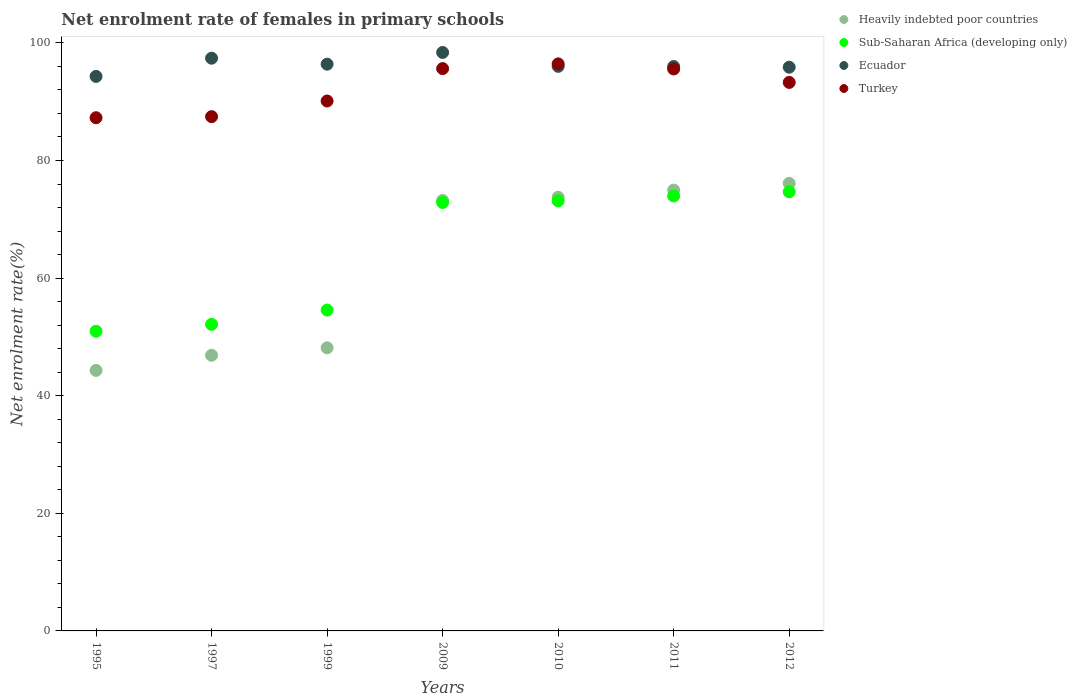What is the net enrolment rate of females in primary schools in Ecuador in 2009?
Keep it short and to the point. 98.37. Across all years, what is the maximum net enrolment rate of females in primary schools in Sub-Saharan Africa (developing only)?
Keep it short and to the point. 74.68. Across all years, what is the minimum net enrolment rate of females in primary schools in Heavily indebted poor countries?
Your answer should be very brief. 44.31. What is the total net enrolment rate of females in primary schools in Turkey in the graph?
Give a very brief answer. 645.75. What is the difference between the net enrolment rate of females in primary schools in Turkey in 2009 and that in 2010?
Your answer should be very brief. -0.8. What is the difference between the net enrolment rate of females in primary schools in Ecuador in 2011 and the net enrolment rate of females in primary schools in Sub-Saharan Africa (developing only) in 2010?
Your response must be concise. 22.84. What is the average net enrolment rate of females in primary schools in Heavily indebted poor countries per year?
Offer a very short reply. 62.48. In the year 2009, what is the difference between the net enrolment rate of females in primary schools in Sub-Saharan Africa (developing only) and net enrolment rate of females in primary schools in Ecuador?
Your response must be concise. -25.51. What is the ratio of the net enrolment rate of females in primary schools in Sub-Saharan Africa (developing only) in 1997 to that in 2011?
Ensure brevity in your answer.  0.7. Is the difference between the net enrolment rate of females in primary schools in Sub-Saharan Africa (developing only) in 1995 and 2009 greater than the difference between the net enrolment rate of females in primary schools in Ecuador in 1995 and 2009?
Ensure brevity in your answer.  No. What is the difference between the highest and the second highest net enrolment rate of females in primary schools in Heavily indebted poor countries?
Your response must be concise. 1.14. What is the difference between the highest and the lowest net enrolment rate of females in primary schools in Heavily indebted poor countries?
Provide a succinct answer. 31.81. Is the sum of the net enrolment rate of females in primary schools in Turkey in 1997 and 1999 greater than the maximum net enrolment rate of females in primary schools in Sub-Saharan Africa (developing only) across all years?
Ensure brevity in your answer.  Yes. Is it the case that in every year, the sum of the net enrolment rate of females in primary schools in Sub-Saharan Africa (developing only) and net enrolment rate of females in primary schools in Ecuador  is greater than the net enrolment rate of females in primary schools in Turkey?
Your answer should be very brief. Yes. Is the net enrolment rate of females in primary schools in Turkey strictly greater than the net enrolment rate of females in primary schools in Heavily indebted poor countries over the years?
Make the answer very short. Yes. How many years are there in the graph?
Offer a terse response. 7. Does the graph contain any zero values?
Make the answer very short. No. How are the legend labels stacked?
Your answer should be compact. Vertical. What is the title of the graph?
Provide a short and direct response. Net enrolment rate of females in primary schools. What is the label or title of the Y-axis?
Keep it short and to the point. Net enrolment rate(%). What is the Net enrolment rate(%) of Heavily indebted poor countries in 1995?
Your response must be concise. 44.31. What is the Net enrolment rate(%) of Sub-Saharan Africa (developing only) in 1995?
Offer a very short reply. 50.96. What is the Net enrolment rate(%) in Ecuador in 1995?
Your response must be concise. 94.3. What is the Net enrolment rate(%) in Turkey in 1995?
Offer a terse response. 87.27. What is the Net enrolment rate(%) in Heavily indebted poor countries in 1997?
Offer a very short reply. 46.88. What is the Net enrolment rate(%) in Sub-Saharan Africa (developing only) in 1997?
Your response must be concise. 52.14. What is the Net enrolment rate(%) of Ecuador in 1997?
Make the answer very short. 97.4. What is the Net enrolment rate(%) of Turkey in 1997?
Keep it short and to the point. 87.46. What is the Net enrolment rate(%) in Heavily indebted poor countries in 1999?
Your answer should be very brief. 48.15. What is the Net enrolment rate(%) in Sub-Saharan Africa (developing only) in 1999?
Your answer should be compact. 54.56. What is the Net enrolment rate(%) of Ecuador in 1999?
Give a very brief answer. 96.38. What is the Net enrolment rate(%) in Turkey in 1999?
Give a very brief answer. 90.12. What is the Net enrolment rate(%) of Heavily indebted poor countries in 2009?
Your response must be concise. 73.21. What is the Net enrolment rate(%) of Sub-Saharan Africa (developing only) in 2009?
Offer a very short reply. 72.86. What is the Net enrolment rate(%) of Ecuador in 2009?
Make the answer very short. 98.37. What is the Net enrolment rate(%) of Turkey in 2009?
Your answer should be very brief. 95.63. What is the Net enrolment rate(%) of Heavily indebted poor countries in 2010?
Provide a short and direct response. 73.75. What is the Net enrolment rate(%) of Sub-Saharan Africa (developing only) in 2010?
Your answer should be very brief. 73.14. What is the Net enrolment rate(%) in Ecuador in 2010?
Your answer should be compact. 96.01. What is the Net enrolment rate(%) of Turkey in 2010?
Offer a very short reply. 96.43. What is the Net enrolment rate(%) in Heavily indebted poor countries in 2011?
Your answer should be compact. 74.97. What is the Net enrolment rate(%) of Sub-Saharan Africa (developing only) in 2011?
Give a very brief answer. 73.96. What is the Net enrolment rate(%) in Ecuador in 2011?
Make the answer very short. 95.98. What is the Net enrolment rate(%) in Turkey in 2011?
Your answer should be very brief. 95.57. What is the Net enrolment rate(%) of Heavily indebted poor countries in 2012?
Keep it short and to the point. 76.11. What is the Net enrolment rate(%) in Sub-Saharan Africa (developing only) in 2012?
Offer a terse response. 74.68. What is the Net enrolment rate(%) of Ecuador in 2012?
Offer a terse response. 95.87. What is the Net enrolment rate(%) in Turkey in 2012?
Your answer should be compact. 93.28. Across all years, what is the maximum Net enrolment rate(%) in Heavily indebted poor countries?
Ensure brevity in your answer.  76.11. Across all years, what is the maximum Net enrolment rate(%) in Sub-Saharan Africa (developing only)?
Give a very brief answer. 74.68. Across all years, what is the maximum Net enrolment rate(%) of Ecuador?
Offer a terse response. 98.37. Across all years, what is the maximum Net enrolment rate(%) in Turkey?
Offer a terse response. 96.43. Across all years, what is the minimum Net enrolment rate(%) of Heavily indebted poor countries?
Your response must be concise. 44.31. Across all years, what is the minimum Net enrolment rate(%) in Sub-Saharan Africa (developing only)?
Provide a succinct answer. 50.96. Across all years, what is the minimum Net enrolment rate(%) of Ecuador?
Give a very brief answer. 94.3. Across all years, what is the minimum Net enrolment rate(%) of Turkey?
Offer a very short reply. 87.27. What is the total Net enrolment rate(%) in Heavily indebted poor countries in the graph?
Ensure brevity in your answer.  437.37. What is the total Net enrolment rate(%) in Sub-Saharan Africa (developing only) in the graph?
Your response must be concise. 452.31. What is the total Net enrolment rate(%) of Ecuador in the graph?
Offer a terse response. 674.32. What is the total Net enrolment rate(%) of Turkey in the graph?
Provide a short and direct response. 645.75. What is the difference between the Net enrolment rate(%) in Heavily indebted poor countries in 1995 and that in 1997?
Make the answer very short. -2.57. What is the difference between the Net enrolment rate(%) in Sub-Saharan Africa (developing only) in 1995 and that in 1997?
Provide a succinct answer. -1.18. What is the difference between the Net enrolment rate(%) of Ecuador in 1995 and that in 1997?
Provide a short and direct response. -3.1. What is the difference between the Net enrolment rate(%) in Turkey in 1995 and that in 1997?
Keep it short and to the point. -0.18. What is the difference between the Net enrolment rate(%) of Heavily indebted poor countries in 1995 and that in 1999?
Provide a short and direct response. -3.84. What is the difference between the Net enrolment rate(%) in Sub-Saharan Africa (developing only) in 1995 and that in 1999?
Keep it short and to the point. -3.6. What is the difference between the Net enrolment rate(%) of Ecuador in 1995 and that in 1999?
Keep it short and to the point. -2.08. What is the difference between the Net enrolment rate(%) in Turkey in 1995 and that in 1999?
Give a very brief answer. -2.85. What is the difference between the Net enrolment rate(%) of Heavily indebted poor countries in 1995 and that in 2009?
Your answer should be compact. -28.9. What is the difference between the Net enrolment rate(%) of Sub-Saharan Africa (developing only) in 1995 and that in 2009?
Your answer should be very brief. -21.9. What is the difference between the Net enrolment rate(%) in Ecuador in 1995 and that in 2009?
Keep it short and to the point. -4.07. What is the difference between the Net enrolment rate(%) in Turkey in 1995 and that in 2009?
Your answer should be compact. -8.36. What is the difference between the Net enrolment rate(%) of Heavily indebted poor countries in 1995 and that in 2010?
Make the answer very short. -29.44. What is the difference between the Net enrolment rate(%) of Sub-Saharan Africa (developing only) in 1995 and that in 2010?
Make the answer very short. -22.18. What is the difference between the Net enrolment rate(%) in Ecuador in 1995 and that in 2010?
Offer a very short reply. -1.71. What is the difference between the Net enrolment rate(%) of Turkey in 1995 and that in 2010?
Provide a succinct answer. -9.16. What is the difference between the Net enrolment rate(%) of Heavily indebted poor countries in 1995 and that in 2011?
Give a very brief answer. -30.66. What is the difference between the Net enrolment rate(%) in Sub-Saharan Africa (developing only) in 1995 and that in 2011?
Your answer should be compact. -23. What is the difference between the Net enrolment rate(%) in Ecuador in 1995 and that in 2011?
Make the answer very short. -1.68. What is the difference between the Net enrolment rate(%) in Turkey in 1995 and that in 2011?
Offer a terse response. -8.3. What is the difference between the Net enrolment rate(%) of Heavily indebted poor countries in 1995 and that in 2012?
Your answer should be very brief. -31.81. What is the difference between the Net enrolment rate(%) of Sub-Saharan Africa (developing only) in 1995 and that in 2012?
Your answer should be very brief. -23.72. What is the difference between the Net enrolment rate(%) in Ecuador in 1995 and that in 2012?
Give a very brief answer. -1.56. What is the difference between the Net enrolment rate(%) in Turkey in 1995 and that in 2012?
Offer a terse response. -6.01. What is the difference between the Net enrolment rate(%) in Heavily indebted poor countries in 1997 and that in 1999?
Your answer should be compact. -1.27. What is the difference between the Net enrolment rate(%) in Sub-Saharan Africa (developing only) in 1997 and that in 1999?
Provide a short and direct response. -2.42. What is the difference between the Net enrolment rate(%) in Ecuador in 1997 and that in 1999?
Provide a short and direct response. 1.02. What is the difference between the Net enrolment rate(%) in Turkey in 1997 and that in 1999?
Give a very brief answer. -2.66. What is the difference between the Net enrolment rate(%) of Heavily indebted poor countries in 1997 and that in 2009?
Provide a short and direct response. -26.33. What is the difference between the Net enrolment rate(%) of Sub-Saharan Africa (developing only) in 1997 and that in 2009?
Your answer should be compact. -20.72. What is the difference between the Net enrolment rate(%) in Ecuador in 1997 and that in 2009?
Give a very brief answer. -0.97. What is the difference between the Net enrolment rate(%) in Turkey in 1997 and that in 2009?
Your answer should be very brief. -8.17. What is the difference between the Net enrolment rate(%) in Heavily indebted poor countries in 1997 and that in 2010?
Give a very brief answer. -26.87. What is the difference between the Net enrolment rate(%) of Sub-Saharan Africa (developing only) in 1997 and that in 2010?
Provide a succinct answer. -21. What is the difference between the Net enrolment rate(%) in Ecuador in 1997 and that in 2010?
Make the answer very short. 1.38. What is the difference between the Net enrolment rate(%) in Turkey in 1997 and that in 2010?
Keep it short and to the point. -8.97. What is the difference between the Net enrolment rate(%) of Heavily indebted poor countries in 1997 and that in 2011?
Ensure brevity in your answer.  -28.09. What is the difference between the Net enrolment rate(%) in Sub-Saharan Africa (developing only) in 1997 and that in 2011?
Offer a terse response. -21.82. What is the difference between the Net enrolment rate(%) of Ecuador in 1997 and that in 2011?
Provide a short and direct response. 1.41. What is the difference between the Net enrolment rate(%) in Turkey in 1997 and that in 2011?
Offer a very short reply. -8.11. What is the difference between the Net enrolment rate(%) of Heavily indebted poor countries in 1997 and that in 2012?
Keep it short and to the point. -29.24. What is the difference between the Net enrolment rate(%) of Sub-Saharan Africa (developing only) in 1997 and that in 2012?
Provide a short and direct response. -22.54. What is the difference between the Net enrolment rate(%) of Ecuador in 1997 and that in 2012?
Offer a very short reply. 1.53. What is the difference between the Net enrolment rate(%) of Turkey in 1997 and that in 2012?
Provide a short and direct response. -5.82. What is the difference between the Net enrolment rate(%) in Heavily indebted poor countries in 1999 and that in 2009?
Your response must be concise. -25.06. What is the difference between the Net enrolment rate(%) of Sub-Saharan Africa (developing only) in 1999 and that in 2009?
Provide a short and direct response. -18.3. What is the difference between the Net enrolment rate(%) of Ecuador in 1999 and that in 2009?
Offer a terse response. -1.99. What is the difference between the Net enrolment rate(%) in Turkey in 1999 and that in 2009?
Give a very brief answer. -5.51. What is the difference between the Net enrolment rate(%) in Heavily indebted poor countries in 1999 and that in 2010?
Provide a short and direct response. -25.6. What is the difference between the Net enrolment rate(%) in Sub-Saharan Africa (developing only) in 1999 and that in 2010?
Offer a very short reply. -18.58. What is the difference between the Net enrolment rate(%) of Ecuador in 1999 and that in 2010?
Provide a short and direct response. 0.37. What is the difference between the Net enrolment rate(%) in Turkey in 1999 and that in 2010?
Your answer should be compact. -6.31. What is the difference between the Net enrolment rate(%) of Heavily indebted poor countries in 1999 and that in 2011?
Offer a terse response. -26.82. What is the difference between the Net enrolment rate(%) of Sub-Saharan Africa (developing only) in 1999 and that in 2011?
Offer a very short reply. -19.4. What is the difference between the Net enrolment rate(%) of Ecuador in 1999 and that in 2011?
Provide a short and direct response. 0.4. What is the difference between the Net enrolment rate(%) in Turkey in 1999 and that in 2011?
Provide a short and direct response. -5.45. What is the difference between the Net enrolment rate(%) in Heavily indebted poor countries in 1999 and that in 2012?
Ensure brevity in your answer.  -27.97. What is the difference between the Net enrolment rate(%) in Sub-Saharan Africa (developing only) in 1999 and that in 2012?
Offer a terse response. -20.12. What is the difference between the Net enrolment rate(%) in Ecuador in 1999 and that in 2012?
Your response must be concise. 0.52. What is the difference between the Net enrolment rate(%) of Turkey in 1999 and that in 2012?
Provide a short and direct response. -3.16. What is the difference between the Net enrolment rate(%) in Heavily indebted poor countries in 2009 and that in 2010?
Your response must be concise. -0.54. What is the difference between the Net enrolment rate(%) in Sub-Saharan Africa (developing only) in 2009 and that in 2010?
Your answer should be very brief. -0.28. What is the difference between the Net enrolment rate(%) of Ecuador in 2009 and that in 2010?
Your response must be concise. 2.36. What is the difference between the Net enrolment rate(%) of Turkey in 2009 and that in 2010?
Give a very brief answer. -0.8. What is the difference between the Net enrolment rate(%) of Heavily indebted poor countries in 2009 and that in 2011?
Your answer should be very brief. -1.76. What is the difference between the Net enrolment rate(%) of Sub-Saharan Africa (developing only) in 2009 and that in 2011?
Your answer should be very brief. -1.1. What is the difference between the Net enrolment rate(%) of Ecuador in 2009 and that in 2011?
Your response must be concise. 2.39. What is the difference between the Net enrolment rate(%) of Turkey in 2009 and that in 2011?
Your answer should be compact. 0.06. What is the difference between the Net enrolment rate(%) in Heavily indebted poor countries in 2009 and that in 2012?
Offer a very short reply. -2.91. What is the difference between the Net enrolment rate(%) in Sub-Saharan Africa (developing only) in 2009 and that in 2012?
Your response must be concise. -1.82. What is the difference between the Net enrolment rate(%) of Ecuador in 2009 and that in 2012?
Give a very brief answer. 2.5. What is the difference between the Net enrolment rate(%) in Turkey in 2009 and that in 2012?
Your response must be concise. 2.35. What is the difference between the Net enrolment rate(%) in Heavily indebted poor countries in 2010 and that in 2011?
Provide a succinct answer. -1.22. What is the difference between the Net enrolment rate(%) in Sub-Saharan Africa (developing only) in 2010 and that in 2011?
Provide a succinct answer. -0.82. What is the difference between the Net enrolment rate(%) in Ecuador in 2010 and that in 2011?
Provide a succinct answer. 0.03. What is the difference between the Net enrolment rate(%) in Turkey in 2010 and that in 2011?
Your answer should be very brief. 0.86. What is the difference between the Net enrolment rate(%) of Heavily indebted poor countries in 2010 and that in 2012?
Give a very brief answer. -2.37. What is the difference between the Net enrolment rate(%) of Sub-Saharan Africa (developing only) in 2010 and that in 2012?
Provide a succinct answer. -1.54. What is the difference between the Net enrolment rate(%) in Ecuador in 2010 and that in 2012?
Keep it short and to the point. 0.15. What is the difference between the Net enrolment rate(%) in Turkey in 2010 and that in 2012?
Your answer should be compact. 3.15. What is the difference between the Net enrolment rate(%) in Heavily indebted poor countries in 2011 and that in 2012?
Ensure brevity in your answer.  -1.14. What is the difference between the Net enrolment rate(%) of Sub-Saharan Africa (developing only) in 2011 and that in 2012?
Provide a succinct answer. -0.72. What is the difference between the Net enrolment rate(%) in Ecuador in 2011 and that in 2012?
Offer a very short reply. 0.12. What is the difference between the Net enrolment rate(%) in Turkey in 2011 and that in 2012?
Provide a short and direct response. 2.29. What is the difference between the Net enrolment rate(%) in Heavily indebted poor countries in 1995 and the Net enrolment rate(%) in Sub-Saharan Africa (developing only) in 1997?
Keep it short and to the point. -7.83. What is the difference between the Net enrolment rate(%) of Heavily indebted poor countries in 1995 and the Net enrolment rate(%) of Ecuador in 1997?
Your answer should be very brief. -53.09. What is the difference between the Net enrolment rate(%) of Heavily indebted poor countries in 1995 and the Net enrolment rate(%) of Turkey in 1997?
Your answer should be compact. -43.15. What is the difference between the Net enrolment rate(%) in Sub-Saharan Africa (developing only) in 1995 and the Net enrolment rate(%) in Ecuador in 1997?
Offer a terse response. -46.44. What is the difference between the Net enrolment rate(%) of Sub-Saharan Africa (developing only) in 1995 and the Net enrolment rate(%) of Turkey in 1997?
Make the answer very short. -36.5. What is the difference between the Net enrolment rate(%) of Ecuador in 1995 and the Net enrolment rate(%) of Turkey in 1997?
Give a very brief answer. 6.85. What is the difference between the Net enrolment rate(%) of Heavily indebted poor countries in 1995 and the Net enrolment rate(%) of Sub-Saharan Africa (developing only) in 1999?
Offer a very short reply. -10.26. What is the difference between the Net enrolment rate(%) of Heavily indebted poor countries in 1995 and the Net enrolment rate(%) of Ecuador in 1999?
Ensure brevity in your answer.  -52.08. What is the difference between the Net enrolment rate(%) of Heavily indebted poor countries in 1995 and the Net enrolment rate(%) of Turkey in 1999?
Make the answer very short. -45.81. What is the difference between the Net enrolment rate(%) of Sub-Saharan Africa (developing only) in 1995 and the Net enrolment rate(%) of Ecuador in 1999?
Offer a very short reply. -45.42. What is the difference between the Net enrolment rate(%) in Sub-Saharan Africa (developing only) in 1995 and the Net enrolment rate(%) in Turkey in 1999?
Your answer should be compact. -39.16. What is the difference between the Net enrolment rate(%) in Ecuador in 1995 and the Net enrolment rate(%) in Turkey in 1999?
Offer a terse response. 4.18. What is the difference between the Net enrolment rate(%) in Heavily indebted poor countries in 1995 and the Net enrolment rate(%) in Sub-Saharan Africa (developing only) in 2009?
Your response must be concise. -28.56. What is the difference between the Net enrolment rate(%) in Heavily indebted poor countries in 1995 and the Net enrolment rate(%) in Ecuador in 2009?
Your answer should be compact. -54.07. What is the difference between the Net enrolment rate(%) of Heavily indebted poor countries in 1995 and the Net enrolment rate(%) of Turkey in 2009?
Keep it short and to the point. -51.32. What is the difference between the Net enrolment rate(%) in Sub-Saharan Africa (developing only) in 1995 and the Net enrolment rate(%) in Ecuador in 2009?
Make the answer very short. -47.41. What is the difference between the Net enrolment rate(%) of Sub-Saharan Africa (developing only) in 1995 and the Net enrolment rate(%) of Turkey in 2009?
Give a very brief answer. -44.67. What is the difference between the Net enrolment rate(%) of Ecuador in 1995 and the Net enrolment rate(%) of Turkey in 2009?
Give a very brief answer. -1.33. What is the difference between the Net enrolment rate(%) in Heavily indebted poor countries in 1995 and the Net enrolment rate(%) in Sub-Saharan Africa (developing only) in 2010?
Your answer should be compact. -28.84. What is the difference between the Net enrolment rate(%) of Heavily indebted poor countries in 1995 and the Net enrolment rate(%) of Ecuador in 2010?
Provide a succinct answer. -51.71. What is the difference between the Net enrolment rate(%) of Heavily indebted poor countries in 1995 and the Net enrolment rate(%) of Turkey in 2010?
Your response must be concise. -52.12. What is the difference between the Net enrolment rate(%) of Sub-Saharan Africa (developing only) in 1995 and the Net enrolment rate(%) of Ecuador in 2010?
Offer a terse response. -45.06. What is the difference between the Net enrolment rate(%) in Sub-Saharan Africa (developing only) in 1995 and the Net enrolment rate(%) in Turkey in 2010?
Give a very brief answer. -45.47. What is the difference between the Net enrolment rate(%) in Ecuador in 1995 and the Net enrolment rate(%) in Turkey in 2010?
Make the answer very short. -2.13. What is the difference between the Net enrolment rate(%) of Heavily indebted poor countries in 1995 and the Net enrolment rate(%) of Sub-Saharan Africa (developing only) in 2011?
Your response must be concise. -29.66. What is the difference between the Net enrolment rate(%) in Heavily indebted poor countries in 1995 and the Net enrolment rate(%) in Ecuador in 2011?
Your response must be concise. -51.68. What is the difference between the Net enrolment rate(%) of Heavily indebted poor countries in 1995 and the Net enrolment rate(%) of Turkey in 2011?
Make the answer very short. -51.26. What is the difference between the Net enrolment rate(%) of Sub-Saharan Africa (developing only) in 1995 and the Net enrolment rate(%) of Ecuador in 2011?
Make the answer very short. -45.02. What is the difference between the Net enrolment rate(%) of Sub-Saharan Africa (developing only) in 1995 and the Net enrolment rate(%) of Turkey in 2011?
Ensure brevity in your answer.  -44.61. What is the difference between the Net enrolment rate(%) in Ecuador in 1995 and the Net enrolment rate(%) in Turkey in 2011?
Keep it short and to the point. -1.27. What is the difference between the Net enrolment rate(%) of Heavily indebted poor countries in 1995 and the Net enrolment rate(%) of Sub-Saharan Africa (developing only) in 2012?
Your answer should be compact. -30.38. What is the difference between the Net enrolment rate(%) of Heavily indebted poor countries in 1995 and the Net enrolment rate(%) of Ecuador in 2012?
Your answer should be very brief. -51.56. What is the difference between the Net enrolment rate(%) in Heavily indebted poor countries in 1995 and the Net enrolment rate(%) in Turkey in 2012?
Ensure brevity in your answer.  -48.97. What is the difference between the Net enrolment rate(%) in Sub-Saharan Africa (developing only) in 1995 and the Net enrolment rate(%) in Ecuador in 2012?
Your answer should be very brief. -44.91. What is the difference between the Net enrolment rate(%) in Sub-Saharan Africa (developing only) in 1995 and the Net enrolment rate(%) in Turkey in 2012?
Provide a succinct answer. -42.32. What is the difference between the Net enrolment rate(%) in Ecuador in 1995 and the Net enrolment rate(%) in Turkey in 2012?
Your answer should be compact. 1.02. What is the difference between the Net enrolment rate(%) of Heavily indebted poor countries in 1997 and the Net enrolment rate(%) of Sub-Saharan Africa (developing only) in 1999?
Keep it short and to the point. -7.69. What is the difference between the Net enrolment rate(%) in Heavily indebted poor countries in 1997 and the Net enrolment rate(%) in Ecuador in 1999?
Your response must be concise. -49.5. What is the difference between the Net enrolment rate(%) of Heavily indebted poor countries in 1997 and the Net enrolment rate(%) of Turkey in 1999?
Provide a short and direct response. -43.24. What is the difference between the Net enrolment rate(%) in Sub-Saharan Africa (developing only) in 1997 and the Net enrolment rate(%) in Ecuador in 1999?
Make the answer very short. -44.24. What is the difference between the Net enrolment rate(%) of Sub-Saharan Africa (developing only) in 1997 and the Net enrolment rate(%) of Turkey in 1999?
Offer a very short reply. -37.98. What is the difference between the Net enrolment rate(%) of Ecuador in 1997 and the Net enrolment rate(%) of Turkey in 1999?
Provide a short and direct response. 7.28. What is the difference between the Net enrolment rate(%) of Heavily indebted poor countries in 1997 and the Net enrolment rate(%) of Sub-Saharan Africa (developing only) in 2009?
Keep it short and to the point. -25.98. What is the difference between the Net enrolment rate(%) in Heavily indebted poor countries in 1997 and the Net enrolment rate(%) in Ecuador in 2009?
Give a very brief answer. -51.49. What is the difference between the Net enrolment rate(%) in Heavily indebted poor countries in 1997 and the Net enrolment rate(%) in Turkey in 2009?
Ensure brevity in your answer.  -48.75. What is the difference between the Net enrolment rate(%) in Sub-Saharan Africa (developing only) in 1997 and the Net enrolment rate(%) in Ecuador in 2009?
Make the answer very short. -46.23. What is the difference between the Net enrolment rate(%) in Sub-Saharan Africa (developing only) in 1997 and the Net enrolment rate(%) in Turkey in 2009?
Give a very brief answer. -43.49. What is the difference between the Net enrolment rate(%) in Ecuador in 1997 and the Net enrolment rate(%) in Turkey in 2009?
Your response must be concise. 1.77. What is the difference between the Net enrolment rate(%) of Heavily indebted poor countries in 1997 and the Net enrolment rate(%) of Sub-Saharan Africa (developing only) in 2010?
Make the answer very short. -26.26. What is the difference between the Net enrolment rate(%) of Heavily indebted poor countries in 1997 and the Net enrolment rate(%) of Ecuador in 2010?
Provide a short and direct response. -49.14. What is the difference between the Net enrolment rate(%) in Heavily indebted poor countries in 1997 and the Net enrolment rate(%) in Turkey in 2010?
Ensure brevity in your answer.  -49.55. What is the difference between the Net enrolment rate(%) in Sub-Saharan Africa (developing only) in 1997 and the Net enrolment rate(%) in Ecuador in 2010?
Your answer should be very brief. -43.88. What is the difference between the Net enrolment rate(%) in Sub-Saharan Africa (developing only) in 1997 and the Net enrolment rate(%) in Turkey in 2010?
Ensure brevity in your answer.  -44.29. What is the difference between the Net enrolment rate(%) in Ecuador in 1997 and the Net enrolment rate(%) in Turkey in 2010?
Ensure brevity in your answer.  0.97. What is the difference between the Net enrolment rate(%) in Heavily indebted poor countries in 1997 and the Net enrolment rate(%) in Sub-Saharan Africa (developing only) in 2011?
Offer a terse response. -27.09. What is the difference between the Net enrolment rate(%) in Heavily indebted poor countries in 1997 and the Net enrolment rate(%) in Ecuador in 2011?
Make the answer very short. -49.11. What is the difference between the Net enrolment rate(%) in Heavily indebted poor countries in 1997 and the Net enrolment rate(%) in Turkey in 2011?
Your answer should be very brief. -48.69. What is the difference between the Net enrolment rate(%) in Sub-Saharan Africa (developing only) in 1997 and the Net enrolment rate(%) in Ecuador in 2011?
Your response must be concise. -43.84. What is the difference between the Net enrolment rate(%) in Sub-Saharan Africa (developing only) in 1997 and the Net enrolment rate(%) in Turkey in 2011?
Make the answer very short. -43.43. What is the difference between the Net enrolment rate(%) in Ecuador in 1997 and the Net enrolment rate(%) in Turkey in 2011?
Keep it short and to the point. 1.83. What is the difference between the Net enrolment rate(%) of Heavily indebted poor countries in 1997 and the Net enrolment rate(%) of Sub-Saharan Africa (developing only) in 2012?
Your answer should be very brief. -27.81. What is the difference between the Net enrolment rate(%) in Heavily indebted poor countries in 1997 and the Net enrolment rate(%) in Ecuador in 2012?
Your answer should be compact. -48.99. What is the difference between the Net enrolment rate(%) in Heavily indebted poor countries in 1997 and the Net enrolment rate(%) in Turkey in 2012?
Your answer should be compact. -46.4. What is the difference between the Net enrolment rate(%) of Sub-Saharan Africa (developing only) in 1997 and the Net enrolment rate(%) of Ecuador in 2012?
Make the answer very short. -43.73. What is the difference between the Net enrolment rate(%) of Sub-Saharan Africa (developing only) in 1997 and the Net enrolment rate(%) of Turkey in 2012?
Your response must be concise. -41.14. What is the difference between the Net enrolment rate(%) in Ecuador in 1997 and the Net enrolment rate(%) in Turkey in 2012?
Offer a terse response. 4.12. What is the difference between the Net enrolment rate(%) of Heavily indebted poor countries in 1999 and the Net enrolment rate(%) of Sub-Saharan Africa (developing only) in 2009?
Offer a terse response. -24.72. What is the difference between the Net enrolment rate(%) of Heavily indebted poor countries in 1999 and the Net enrolment rate(%) of Ecuador in 2009?
Provide a succinct answer. -50.23. What is the difference between the Net enrolment rate(%) of Heavily indebted poor countries in 1999 and the Net enrolment rate(%) of Turkey in 2009?
Offer a terse response. -47.48. What is the difference between the Net enrolment rate(%) of Sub-Saharan Africa (developing only) in 1999 and the Net enrolment rate(%) of Ecuador in 2009?
Make the answer very short. -43.81. What is the difference between the Net enrolment rate(%) in Sub-Saharan Africa (developing only) in 1999 and the Net enrolment rate(%) in Turkey in 2009?
Make the answer very short. -41.06. What is the difference between the Net enrolment rate(%) of Ecuador in 1999 and the Net enrolment rate(%) of Turkey in 2009?
Make the answer very short. 0.75. What is the difference between the Net enrolment rate(%) of Heavily indebted poor countries in 1999 and the Net enrolment rate(%) of Sub-Saharan Africa (developing only) in 2010?
Offer a very short reply. -25. What is the difference between the Net enrolment rate(%) of Heavily indebted poor countries in 1999 and the Net enrolment rate(%) of Ecuador in 2010?
Give a very brief answer. -47.87. What is the difference between the Net enrolment rate(%) of Heavily indebted poor countries in 1999 and the Net enrolment rate(%) of Turkey in 2010?
Make the answer very short. -48.29. What is the difference between the Net enrolment rate(%) in Sub-Saharan Africa (developing only) in 1999 and the Net enrolment rate(%) in Ecuador in 2010?
Your answer should be compact. -41.45. What is the difference between the Net enrolment rate(%) of Sub-Saharan Africa (developing only) in 1999 and the Net enrolment rate(%) of Turkey in 2010?
Keep it short and to the point. -41.87. What is the difference between the Net enrolment rate(%) of Ecuador in 1999 and the Net enrolment rate(%) of Turkey in 2010?
Your response must be concise. -0.05. What is the difference between the Net enrolment rate(%) of Heavily indebted poor countries in 1999 and the Net enrolment rate(%) of Sub-Saharan Africa (developing only) in 2011?
Offer a very short reply. -25.82. What is the difference between the Net enrolment rate(%) in Heavily indebted poor countries in 1999 and the Net enrolment rate(%) in Ecuador in 2011?
Provide a short and direct response. -47.84. What is the difference between the Net enrolment rate(%) of Heavily indebted poor countries in 1999 and the Net enrolment rate(%) of Turkey in 2011?
Ensure brevity in your answer.  -47.42. What is the difference between the Net enrolment rate(%) in Sub-Saharan Africa (developing only) in 1999 and the Net enrolment rate(%) in Ecuador in 2011?
Your answer should be compact. -41.42. What is the difference between the Net enrolment rate(%) of Sub-Saharan Africa (developing only) in 1999 and the Net enrolment rate(%) of Turkey in 2011?
Provide a short and direct response. -41.01. What is the difference between the Net enrolment rate(%) in Ecuador in 1999 and the Net enrolment rate(%) in Turkey in 2011?
Your answer should be very brief. 0.81. What is the difference between the Net enrolment rate(%) in Heavily indebted poor countries in 1999 and the Net enrolment rate(%) in Sub-Saharan Africa (developing only) in 2012?
Your response must be concise. -26.54. What is the difference between the Net enrolment rate(%) of Heavily indebted poor countries in 1999 and the Net enrolment rate(%) of Ecuador in 2012?
Give a very brief answer. -47.72. What is the difference between the Net enrolment rate(%) of Heavily indebted poor countries in 1999 and the Net enrolment rate(%) of Turkey in 2012?
Your answer should be very brief. -45.13. What is the difference between the Net enrolment rate(%) of Sub-Saharan Africa (developing only) in 1999 and the Net enrolment rate(%) of Ecuador in 2012?
Keep it short and to the point. -41.3. What is the difference between the Net enrolment rate(%) in Sub-Saharan Africa (developing only) in 1999 and the Net enrolment rate(%) in Turkey in 2012?
Your response must be concise. -38.72. What is the difference between the Net enrolment rate(%) of Ecuador in 1999 and the Net enrolment rate(%) of Turkey in 2012?
Offer a very short reply. 3.1. What is the difference between the Net enrolment rate(%) in Heavily indebted poor countries in 2009 and the Net enrolment rate(%) in Sub-Saharan Africa (developing only) in 2010?
Provide a short and direct response. 0.06. What is the difference between the Net enrolment rate(%) of Heavily indebted poor countries in 2009 and the Net enrolment rate(%) of Ecuador in 2010?
Your answer should be compact. -22.81. What is the difference between the Net enrolment rate(%) in Heavily indebted poor countries in 2009 and the Net enrolment rate(%) in Turkey in 2010?
Keep it short and to the point. -23.22. What is the difference between the Net enrolment rate(%) of Sub-Saharan Africa (developing only) in 2009 and the Net enrolment rate(%) of Ecuador in 2010?
Offer a very short reply. -23.15. What is the difference between the Net enrolment rate(%) of Sub-Saharan Africa (developing only) in 2009 and the Net enrolment rate(%) of Turkey in 2010?
Your response must be concise. -23.57. What is the difference between the Net enrolment rate(%) in Ecuador in 2009 and the Net enrolment rate(%) in Turkey in 2010?
Your answer should be compact. 1.94. What is the difference between the Net enrolment rate(%) of Heavily indebted poor countries in 2009 and the Net enrolment rate(%) of Sub-Saharan Africa (developing only) in 2011?
Provide a short and direct response. -0.76. What is the difference between the Net enrolment rate(%) of Heavily indebted poor countries in 2009 and the Net enrolment rate(%) of Ecuador in 2011?
Provide a short and direct response. -22.78. What is the difference between the Net enrolment rate(%) in Heavily indebted poor countries in 2009 and the Net enrolment rate(%) in Turkey in 2011?
Your response must be concise. -22.36. What is the difference between the Net enrolment rate(%) in Sub-Saharan Africa (developing only) in 2009 and the Net enrolment rate(%) in Ecuador in 2011?
Keep it short and to the point. -23.12. What is the difference between the Net enrolment rate(%) in Sub-Saharan Africa (developing only) in 2009 and the Net enrolment rate(%) in Turkey in 2011?
Your answer should be compact. -22.71. What is the difference between the Net enrolment rate(%) of Ecuador in 2009 and the Net enrolment rate(%) of Turkey in 2011?
Make the answer very short. 2.8. What is the difference between the Net enrolment rate(%) of Heavily indebted poor countries in 2009 and the Net enrolment rate(%) of Sub-Saharan Africa (developing only) in 2012?
Provide a succinct answer. -1.48. What is the difference between the Net enrolment rate(%) of Heavily indebted poor countries in 2009 and the Net enrolment rate(%) of Ecuador in 2012?
Provide a succinct answer. -22.66. What is the difference between the Net enrolment rate(%) of Heavily indebted poor countries in 2009 and the Net enrolment rate(%) of Turkey in 2012?
Give a very brief answer. -20.07. What is the difference between the Net enrolment rate(%) in Sub-Saharan Africa (developing only) in 2009 and the Net enrolment rate(%) in Ecuador in 2012?
Your answer should be very brief. -23. What is the difference between the Net enrolment rate(%) of Sub-Saharan Africa (developing only) in 2009 and the Net enrolment rate(%) of Turkey in 2012?
Make the answer very short. -20.42. What is the difference between the Net enrolment rate(%) in Ecuador in 2009 and the Net enrolment rate(%) in Turkey in 2012?
Offer a terse response. 5.09. What is the difference between the Net enrolment rate(%) of Heavily indebted poor countries in 2010 and the Net enrolment rate(%) of Sub-Saharan Africa (developing only) in 2011?
Offer a very short reply. -0.21. What is the difference between the Net enrolment rate(%) in Heavily indebted poor countries in 2010 and the Net enrolment rate(%) in Ecuador in 2011?
Give a very brief answer. -22.23. What is the difference between the Net enrolment rate(%) in Heavily indebted poor countries in 2010 and the Net enrolment rate(%) in Turkey in 2011?
Provide a succinct answer. -21.82. What is the difference between the Net enrolment rate(%) of Sub-Saharan Africa (developing only) in 2010 and the Net enrolment rate(%) of Ecuador in 2011?
Give a very brief answer. -22.84. What is the difference between the Net enrolment rate(%) in Sub-Saharan Africa (developing only) in 2010 and the Net enrolment rate(%) in Turkey in 2011?
Your answer should be very brief. -22.43. What is the difference between the Net enrolment rate(%) of Ecuador in 2010 and the Net enrolment rate(%) of Turkey in 2011?
Offer a terse response. 0.45. What is the difference between the Net enrolment rate(%) in Heavily indebted poor countries in 2010 and the Net enrolment rate(%) in Sub-Saharan Africa (developing only) in 2012?
Your answer should be very brief. -0.93. What is the difference between the Net enrolment rate(%) of Heavily indebted poor countries in 2010 and the Net enrolment rate(%) of Ecuador in 2012?
Offer a terse response. -22.12. What is the difference between the Net enrolment rate(%) in Heavily indebted poor countries in 2010 and the Net enrolment rate(%) in Turkey in 2012?
Provide a short and direct response. -19.53. What is the difference between the Net enrolment rate(%) of Sub-Saharan Africa (developing only) in 2010 and the Net enrolment rate(%) of Ecuador in 2012?
Offer a very short reply. -22.72. What is the difference between the Net enrolment rate(%) of Sub-Saharan Africa (developing only) in 2010 and the Net enrolment rate(%) of Turkey in 2012?
Make the answer very short. -20.14. What is the difference between the Net enrolment rate(%) in Ecuador in 2010 and the Net enrolment rate(%) in Turkey in 2012?
Keep it short and to the point. 2.74. What is the difference between the Net enrolment rate(%) of Heavily indebted poor countries in 2011 and the Net enrolment rate(%) of Sub-Saharan Africa (developing only) in 2012?
Give a very brief answer. 0.29. What is the difference between the Net enrolment rate(%) in Heavily indebted poor countries in 2011 and the Net enrolment rate(%) in Ecuador in 2012?
Provide a succinct answer. -20.9. What is the difference between the Net enrolment rate(%) of Heavily indebted poor countries in 2011 and the Net enrolment rate(%) of Turkey in 2012?
Ensure brevity in your answer.  -18.31. What is the difference between the Net enrolment rate(%) of Sub-Saharan Africa (developing only) in 2011 and the Net enrolment rate(%) of Ecuador in 2012?
Offer a terse response. -21.9. What is the difference between the Net enrolment rate(%) of Sub-Saharan Africa (developing only) in 2011 and the Net enrolment rate(%) of Turkey in 2012?
Your response must be concise. -19.32. What is the difference between the Net enrolment rate(%) in Ecuador in 2011 and the Net enrolment rate(%) in Turkey in 2012?
Provide a short and direct response. 2.7. What is the average Net enrolment rate(%) of Heavily indebted poor countries per year?
Offer a very short reply. 62.48. What is the average Net enrolment rate(%) in Sub-Saharan Africa (developing only) per year?
Offer a very short reply. 64.62. What is the average Net enrolment rate(%) of Ecuador per year?
Your answer should be very brief. 96.33. What is the average Net enrolment rate(%) in Turkey per year?
Provide a short and direct response. 92.25. In the year 1995, what is the difference between the Net enrolment rate(%) in Heavily indebted poor countries and Net enrolment rate(%) in Sub-Saharan Africa (developing only)?
Offer a very short reply. -6.65. In the year 1995, what is the difference between the Net enrolment rate(%) of Heavily indebted poor countries and Net enrolment rate(%) of Ecuador?
Keep it short and to the point. -50. In the year 1995, what is the difference between the Net enrolment rate(%) in Heavily indebted poor countries and Net enrolment rate(%) in Turkey?
Your response must be concise. -42.96. In the year 1995, what is the difference between the Net enrolment rate(%) of Sub-Saharan Africa (developing only) and Net enrolment rate(%) of Ecuador?
Ensure brevity in your answer.  -43.34. In the year 1995, what is the difference between the Net enrolment rate(%) of Sub-Saharan Africa (developing only) and Net enrolment rate(%) of Turkey?
Your answer should be very brief. -36.31. In the year 1995, what is the difference between the Net enrolment rate(%) in Ecuador and Net enrolment rate(%) in Turkey?
Your response must be concise. 7.03. In the year 1997, what is the difference between the Net enrolment rate(%) of Heavily indebted poor countries and Net enrolment rate(%) of Sub-Saharan Africa (developing only)?
Give a very brief answer. -5.26. In the year 1997, what is the difference between the Net enrolment rate(%) of Heavily indebted poor countries and Net enrolment rate(%) of Ecuador?
Make the answer very short. -50.52. In the year 1997, what is the difference between the Net enrolment rate(%) in Heavily indebted poor countries and Net enrolment rate(%) in Turkey?
Your answer should be compact. -40.58. In the year 1997, what is the difference between the Net enrolment rate(%) in Sub-Saharan Africa (developing only) and Net enrolment rate(%) in Ecuador?
Give a very brief answer. -45.26. In the year 1997, what is the difference between the Net enrolment rate(%) in Sub-Saharan Africa (developing only) and Net enrolment rate(%) in Turkey?
Ensure brevity in your answer.  -35.32. In the year 1997, what is the difference between the Net enrolment rate(%) of Ecuador and Net enrolment rate(%) of Turkey?
Your answer should be very brief. 9.94. In the year 1999, what is the difference between the Net enrolment rate(%) of Heavily indebted poor countries and Net enrolment rate(%) of Sub-Saharan Africa (developing only)?
Ensure brevity in your answer.  -6.42. In the year 1999, what is the difference between the Net enrolment rate(%) of Heavily indebted poor countries and Net enrolment rate(%) of Ecuador?
Your answer should be very brief. -48.24. In the year 1999, what is the difference between the Net enrolment rate(%) in Heavily indebted poor countries and Net enrolment rate(%) in Turkey?
Your response must be concise. -41.98. In the year 1999, what is the difference between the Net enrolment rate(%) in Sub-Saharan Africa (developing only) and Net enrolment rate(%) in Ecuador?
Give a very brief answer. -41.82. In the year 1999, what is the difference between the Net enrolment rate(%) in Sub-Saharan Africa (developing only) and Net enrolment rate(%) in Turkey?
Ensure brevity in your answer.  -35.56. In the year 1999, what is the difference between the Net enrolment rate(%) in Ecuador and Net enrolment rate(%) in Turkey?
Give a very brief answer. 6.26. In the year 2009, what is the difference between the Net enrolment rate(%) in Heavily indebted poor countries and Net enrolment rate(%) in Sub-Saharan Africa (developing only)?
Provide a succinct answer. 0.35. In the year 2009, what is the difference between the Net enrolment rate(%) of Heavily indebted poor countries and Net enrolment rate(%) of Ecuador?
Your response must be concise. -25.16. In the year 2009, what is the difference between the Net enrolment rate(%) of Heavily indebted poor countries and Net enrolment rate(%) of Turkey?
Provide a short and direct response. -22.42. In the year 2009, what is the difference between the Net enrolment rate(%) in Sub-Saharan Africa (developing only) and Net enrolment rate(%) in Ecuador?
Your answer should be very brief. -25.51. In the year 2009, what is the difference between the Net enrolment rate(%) in Sub-Saharan Africa (developing only) and Net enrolment rate(%) in Turkey?
Provide a succinct answer. -22.77. In the year 2009, what is the difference between the Net enrolment rate(%) in Ecuador and Net enrolment rate(%) in Turkey?
Your response must be concise. 2.74. In the year 2010, what is the difference between the Net enrolment rate(%) in Heavily indebted poor countries and Net enrolment rate(%) in Sub-Saharan Africa (developing only)?
Offer a very short reply. 0.61. In the year 2010, what is the difference between the Net enrolment rate(%) of Heavily indebted poor countries and Net enrolment rate(%) of Ecuador?
Your response must be concise. -22.27. In the year 2010, what is the difference between the Net enrolment rate(%) in Heavily indebted poor countries and Net enrolment rate(%) in Turkey?
Provide a short and direct response. -22.68. In the year 2010, what is the difference between the Net enrolment rate(%) in Sub-Saharan Africa (developing only) and Net enrolment rate(%) in Ecuador?
Provide a succinct answer. -22.87. In the year 2010, what is the difference between the Net enrolment rate(%) of Sub-Saharan Africa (developing only) and Net enrolment rate(%) of Turkey?
Ensure brevity in your answer.  -23.29. In the year 2010, what is the difference between the Net enrolment rate(%) in Ecuador and Net enrolment rate(%) in Turkey?
Your answer should be very brief. -0.42. In the year 2011, what is the difference between the Net enrolment rate(%) in Heavily indebted poor countries and Net enrolment rate(%) in Sub-Saharan Africa (developing only)?
Provide a short and direct response. 1.01. In the year 2011, what is the difference between the Net enrolment rate(%) in Heavily indebted poor countries and Net enrolment rate(%) in Ecuador?
Keep it short and to the point. -21.01. In the year 2011, what is the difference between the Net enrolment rate(%) in Heavily indebted poor countries and Net enrolment rate(%) in Turkey?
Keep it short and to the point. -20.6. In the year 2011, what is the difference between the Net enrolment rate(%) of Sub-Saharan Africa (developing only) and Net enrolment rate(%) of Ecuador?
Give a very brief answer. -22.02. In the year 2011, what is the difference between the Net enrolment rate(%) in Sub-Saharan Africa (developing only) and Net enrolment rate(%) in Turkey?
Make the answer very short. -21.61. In the year 2011, what is the difference between the Net enrolment rate(%) of Ecuador and Net enrolment rate(%) of Turkey?
Offer a very short reply. 0.41. In the year 2012, what is the difference between the Net enrolment rate(%) in Heavily indebted poor countries and Net enrolment rate(%) in Sub-Saharan Africa (developing only)?
Give a very brief answer. 1.43. In the year 2012, what is the difference between the Net enrolment rate(%) of Heavily indebted poor countries and Net enrolment rate(%) of Ecuador?
Make the answer very short. -19.75. In the year 2012, what is the difference between the Net enrolment rate(%) in Heavily indebted poor countries and Net enrolment rate(%) in Turkey?
Give a very brief answer. -17.16. In the year 2012, what is the difference between the Net enrolment rate(%) in Sub-Saharan Africa (developing only) and Net enrolment rate(%) in Ecuador?
Provide a short and direct response. -21.18. In the year 2012, what is the difference between the Net enrolment rate(%) in Sub-Saharan Africa (developing only) and Net enrolment rate(%) in Turkey?
Your answer should be very brief. -18.6. In the year 2012, what is the difference between the Net enrolment rate(%) in Ecuador and Net enrolment rate(%) in Turkey?
Provide a succinct answer. 2.59. What is the ratio of the Net enrolment rate(%) of Heavily indebted poor countries in 1995 to that in 1997?
Your answer should be very brief. 0.95. What is the ratio of the Net enrolment rate(%) in Sub-Saharan Africa (developing only) in 1995 to that in 1997?
Ensure brevity in your answer.  0.98. What is the ratio of the Net enrolment rate(%) of Ecuador in 1995 to that in 1997?
Keep it short and to the point. 0.97. What is the ratio of the Net enrolment rate(%) in Heavily indebted poor countries in 1995 to that in 1999?
Provide a succinct answer. 0.92. What is the ratio of the Net enrolment rate(%) of Sub-Saharan Africa (developing only) in 1995 to that in 1999?
Your response must be concise. 0.93. What is the ratio of the Net enrolment rate(%) of Ecuador in 1995 to that in 1999?
Offer a very short reply. 0.98. What is the ratio of the Net enrolment rate(%) in Turkey in 1995 to that in 1999?
Your response must be concise. 0.97. What is the ratio of the Net enrolment rate(%) in Heavily indebted poor countries in 1995 to that in 2009?
Give a very brief answer. 0.61. What is the ratio of the Net enrolment rate(%) in Sub-Saharan Africa (developing only) in 1995 to that in 2009?
Ensure brevity in your answer.  0.7. What is the ratio of the Net enrolment rate(%) in Ecuador in 1995 to that in 2009?
Your answer should be compact. 0.96. What is the ratio of the Net enrolment rate(%) of Turkey in 1995 to that in 2009?
Ensure brevity in your answer.  0.91. What is the ratio of the Net enrolment rate(%) of Heavily indebted poor countries in 1995 to that in 2010?
Give a very brief answer. 0.6. What is the ratio of the Net enrolment rate(%) in Sub-Saharan Africa (developing only) in 1995 to that in 2010?
Keep it short and to the point. 0.7. What is the ratio of the Net enrolment rate(%) in Ecuador in 1995 to that in 2010?
Make the answer very short. 0.98. What is the ratio of the Net enrolment rate(%) of Turkey in 1995 to that in 2010?
Provide a succinct answer. 0.91. What is the ratio of the Net enrolment rate(%) in Heavily indebted poor countries in 1995 to that in 2011?
Keep it short and to the point. 0.59. What is the ratio of the Net enrolment rate(%) of Sub-Saharan Africa (developing only) in 1995 to that in 2011?
Give a very brief answer. 0.69. What is the ratio of the Net enrolment rate(%) of Ecuador in 1995 to that in 2011?
Ensure brevity in your answer.  0.98. What is the ratio of the Net enrolment rate(%) in Turkey in 1995 to that in 2011?
Offer a terse response. 0.91. What is the ratio of the Net enrolment rate(%) in Heavily indebted poor countries in 1995 to that in 2012?
Give a very brief answer. 0.58. What is the ratio of the Net enrolment rate(%) in Sub-Saharan Africa (developing only) in 1995 to that in 2012?
Offer a terse response. 0.68. What is the ratio of the Net enrolment rate(%) in Ecuador in 1995 to that in 2012?
Offer a terse response. 0.98. What is the ratio of the Net enrolment rate(%) of Turkey in 1995 to that in 2012?
Make the answer very short. 0.94. What is the ratio of the Net enrolment rate(%) of Heavily indebted poor countries in 1997 to that in 1999?
Your answer should be very brief. 0.97. What is the ratio of the Net enrolment rate(%) in Sub-Saharan Africa (developing only) in 1997 to that in 1999?
Ensure brevity in your answer.  0.96. What is the ratio of the Net enrolment rate(%) in Ecuador in 1997 to that in 1999?
Provide a succinct answer. 1.01. What is the ratio of the Net enrolment rate(%) of Turkey in 1997 to that in 1999?
Provide a succinct answer. 0.97. What is the ratio of the Net enrolment rate(%) of Heavily indebted poor countries in 1997 to that in 2009?
Keep it short and to the point. 0.64. What is the ratio of the Net enrolment rate(%) in Sub-Saharan Africa (developing only) in 1997 to that in 2009?
Offer a terse response. 0.72. What is the ratio of the Net enrolment rate(%) in Ecuador in 1997 to that in 2009?
Your answer should be compact. 0.99. What is the ratio of the Net enrolment rate(%) of Turkey in 1997 to that in 2009?
Your answer should be compact. 0.91. What is the ratio of the Net enrolment rate(%) in Heavily indebted poor countries in 1997 to that in 2010?
Your answer should be compact. 0.64. What is the ratio of the Net enrolment rate(%) in Sub-Saharan Africa (developing only) in 1997 to that in 2010?
Your response must be concise. 0.71. What is the ratio of the Net enrolment rate(%) in Ecuador in 1997 to that in 2010?
Offer a terse response. 1.01. What is the ratio of the Net enrolment rate(%) in Turkey in 1997 to that in 2010?
Offer a terse response. 0.91. What is the ratio of the Net enrolment rate(%) of Heavily indebted poor countries in 1997 to that in 2011?
Give a very brief answer. 0.63. What is the ratio of the Net enrolment rate(%) in Sub-Saharan Africa (developing only) in 1997 to that in 2011?
Your response must be concise. 0.7. What is the ratio of the Net enrolment rate(%) of Ecuador in 1997 to that in 2011?
Provide a succinct answer. 1.01. What is the ratio of the Net enrolment rate(%) of Turkey in 1997 to that in 2011?
Provide a succinct answer. 0.92. What is the ratio of the Net enrolment rate(%) in Heavily indebted poor countries in 1997 to that in 2012?
Give a very brief answer. 0.62. What is the ratio of the Net enrolment rate(%) in Sub-Saharan Africa (developing only) in 1997 to that in 2012?
Your response must be concise. 0.7. What is the ratio of the Net enrolment rate(%) of Turkey in 1997 to that in 2012?
Provide a short and direct response. 0.94. What is the ratio of the Net enrolment rate(%) of Heavily indebted poor countries in 1999 to that in 2009?
Your answer should be very brief. 0.66. What is the ratio of the Net enrolment rate(%) of Sub-Saharan Africa (developing only) in 1999 to that in 2009?
Your answer should be compact. 0.75. What is the ratio of the Net enrolment rate(%) of Ecuador in 1999 to that in 2009?
Keep it short and to the point. 0.98. What is the ratio of the Net enrolment rate(%) in Turkey in 1999 to that in 2009?
Keep it short and to the point. 0.94. What is the ratio of the Net enrolment rate(%) in Heavily indebted poor countries in 1999 to that in 2010?
Provide a short and direct response. 0.65. What is the ratio of the Net enrolment rate(%) in Sub-Saharan Africa (developing only) in 1999 to that in 2010?
Offer a terse response. 0.75. What is the ratio of the Net enrolment rate(%) in Turkey in 1999 to that in 2010?
Provide a short and direct response. 0.93. What is the ratio of the Net enrolment rate(%) of Heavily indebted poor countries in 1999 to that in 2011?
Your response must be concise. 0.64. What is the ratio of the Net enrolment rate(%) of Sub-Saharan Africa (developing only) in 1999 to that in 2011?
Provide a short and direct response. 0.74. What is the ratio of the Net enrolment rate(%) in Turkey in 1999 to that in 2011?
Make the answer very short. 0.94. What is the ratio of the Net enrolment rate(%) in Heavily indebted poor countries in 1999 to that in 2012?
Your answer should be very brief. 0.63. What is the ratio of the Net enrolment rate(%) in Sub-Saharan Africa (developing only) in 1999 to that in 2012?
Provide a succinct answer. 0.73. What is the ratio of the Net enrolment rate(%) in Ecuador in 1999 to that in 2012?
Provide a succinct answer. 1.01. What is the ratio of the Net enrolment rate(%) in Turkey in 1999 to that in 2012?
Provide a short and direct response. 0.97. What is the ratio of the Net enrolment rate(%) in Ecuador in 2009 to that in 2010?
Keep it short and to the point. 1.02. What is the ratio of the Net enrolment rate(%) in Turkey in 2009 to that in 2010?
Give a very brief answer. 0.99. What is the ratio of the Net enrolment rate(%) of Heavily indebted poor countries in 2009 to that in 2011?
Your answer should be very brief. 0.98. What is the ratio of the Net enrolment rate(%) in Sub-Saharan Africa (developing only) in 2009 to that in 2011?
Keep it short and to the point. 0.99. What is the ratio of the Net enrolment rate(%) in Ecuador in 2009 to that in 2011?
Provide a short and direct response. 1.02. What is the ratio of the Net enrolment rate(%) of Turkey in 2009 to that in 2011?
Offer a very short reply. 1. What is the ratio of the Net enrolment rate(%) of Heavily indebted poor countries in 2009 to that in 2012?
Your answer should be very brief. 0.96. What is the ratio of the Net enrolment rate(%) in Sub-Saharan Africa (developing only) in 2009 to that in 2012?
Make the answer very short. 0.98. What is the ratio of the Net enrolment rate(%) of Ecuador in 2009 to that in 2012?
Offer a very short reply. 1.03. What is the ratio of the Net enrolment rate(%) in Turkey in 2009 to that in 2012?
Offer a terse response. 1.03. What is the ratio of the Net enrolment rate(%) of Heavily indebted poor countries in 2010 to that in 2011?
Offer a terse response. 0.98. What is the ratio of the Net enrolment rate(%) in Sub-Saharan Africa (developing only) in 2010 to that in 2011?
Your response must be concise. 0.99. What is the ratio of the Net enrolment rate(%) of Ecuador in 2010 to that in 2011?
Provide a short and direct response. 1. What is the ratio of the Net enrolment rate(%) in Heavily indebted poor countries in 2010 to that in 2012?
Offer a terse response. 0.97. What is the ratio of the Net enrolment rate(%) of Sub-Saharan Africa (developing only) in 2010 to that in 2012?
Offer a very short reply. 0.98. What is the ratio of the Net enrolment rate(%) of Turkey in 2010 to that in 2012?
Give a very brief answer. 1.03. What is the ratio of the Net enrolment rate(%) of Heavily indebted poor countries in 2011 to that in 2012?
Your answer should be very brief. 0.98. What is the ratio of the Net enrolment rate(%) of Sub-Saharan Africa (developing only) in 2011 to that in 2012?
Your response must be concise. 0.99. What is the ratio of the Net enrolment rate(%) of Ecuador in 2011 to that in 2012?
Offer a terse response. 1. What is the ratio of the Net enrolment rate(%) of Turkey in 2011 to that in 2012?
Offer a very short reply. 1.02. What is the difference between the highest and the second highest Net enrolment rate(%) of Heavily indebted poor countries?
Ensure brevity in your answer.  1.14. What is the difference between the highest and the second highest Net enrolment rate(%) of Sub-Saharan Africa (developing only)?
Provide a short and direct response. 0.72. What is the difference between the highest and the second highest Net enrolment rate(%) in Ecuador?
Give a very brief answer. 0.97. What is the difference between the highest and the second highest Net enrolment rate(%) of Turkey?
Keep it short and to the point. 0.8. What is the difference between the highest and the lowest Net enrolment rate(%) of Heavily indebted poor countries?
Your answer should be compact. 31.81. What is the difference between the highest and the lowest Net enrolment rate(%) of Sub-Saharan Africa (developing only)?
Give a very brief answer. 23.72. What is the difference between the highest and the lowest Net enrolment rate(%) in Ecuador?
Your answer should be compact. 4.07. What is the difference between the highest and the lowest Net enrolment rate(%) of Turkey?
Make the answer very short. 9.16. 